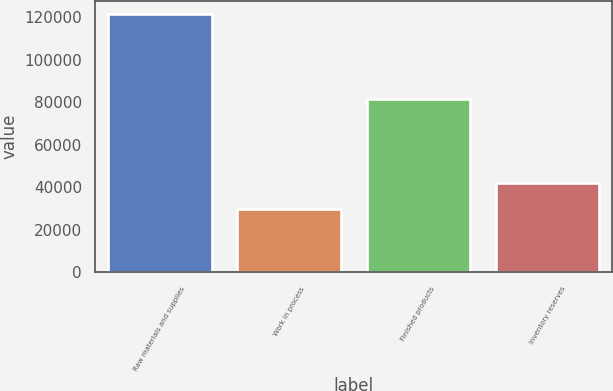Convert chart. <chart><loc_0><loc_0><loc_500><loc_500><bar_chart><fcel>Raw materials and supplies<fcel>Work in process<fcel>Finished products<fcel>Inventory reserves<nl><fcel>121573<fcel>29725<fcel>81536<fcel>41967<nl></chart> 